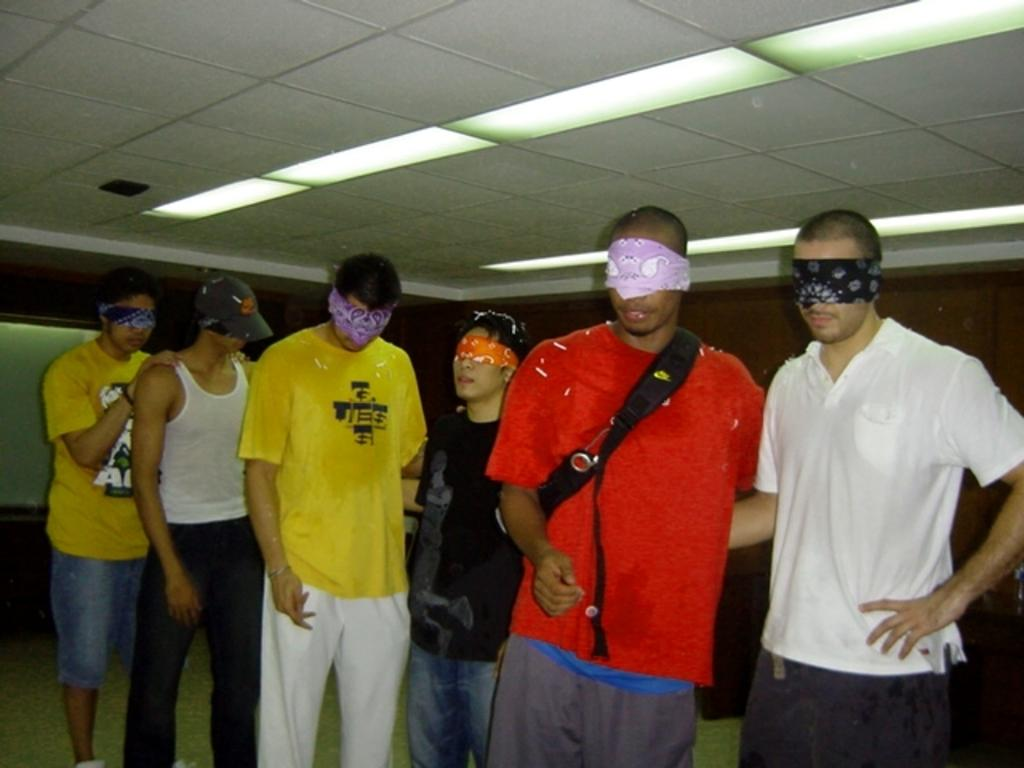What is the main subject of the image? The main subject of the image is a group of people. How can you describe the attire of the people in the image? The people are wearing different color dresses. Can you identify any specific accessory worn by one of the people? One person is wearing a cap. What is a notable feature of the people in the image? The people are blindfolded. What can be seen in the top of the image? There are lights visible in the top of the image. What type of coal is being used to fuel the air in the image? There is no coal or air present in the image; it features a group of blindfolded people with different color dresses and a cap. Can you tell me how many pages are in the book held by one of the people in the image? There is no book present in the image; the people are blindfolded and wearing different color dresses. 